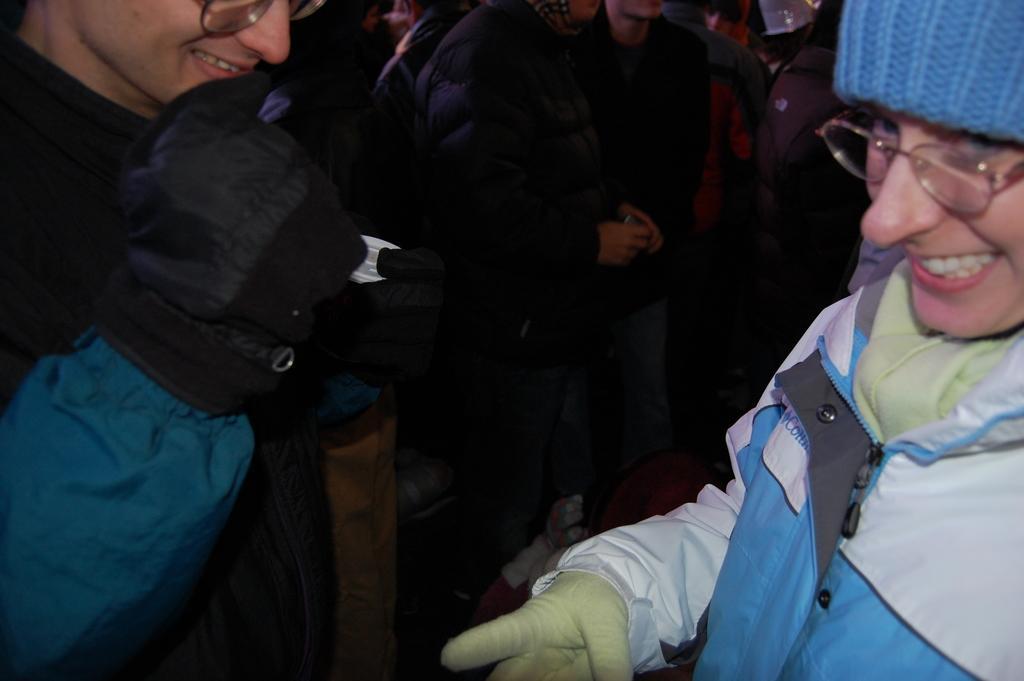How would you summarize this image in a sentence or two? In the foreground of the picture I can see two persons wearing a jacket and there is a smile on their face. In the background, I can see a few people standing on the floor. 